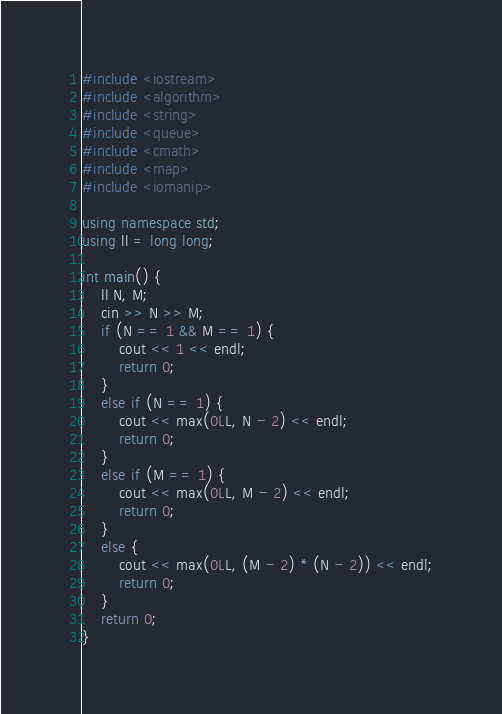Convert code to text. <code><loc_0><loc_0><loc_500><loc_500><_C++_>#include <iostream>
#include <algorithm>
#include <string>
#include <queue>
#include <cmath>
#include <map>
#include <iomanip>

using namespace std;
using ll = long long;

int main() {
	ll N, M;
	cin >> N >> M;
	if (N == 1 && M == 1) {
		cout << 1 << endl;
		return 0;
	}
	else if (N == 1) {
		cout << max(0LL, N - 2) << endl;
		return 0;
	}
	else if (M == 1) {
		cout << max(0LL, M - 2) << endl;
		return 0;
	}
	else {
		cout << max(0LL, (M - 2) * (N - 2)) << endl;
		return 0;
	}
	return 0;
}
</code> 